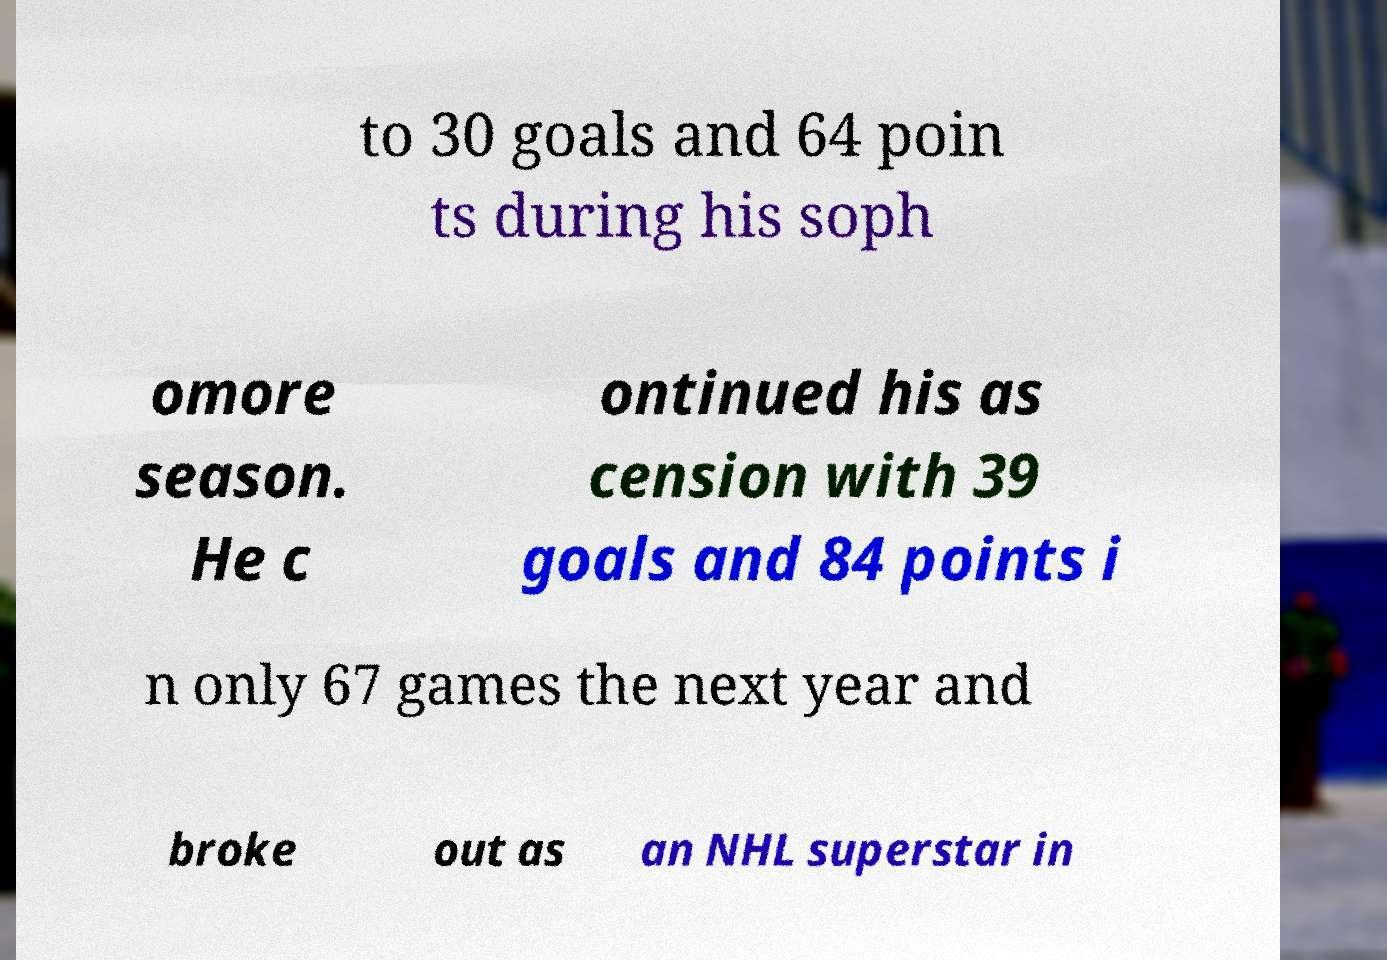I need the written content from this picture converted into text. Can you do that? to 30 goals and 64 poin ts during his soph omore season. He c ontinued his as cension with 39 goals and 84 points i n only 67 games the next year and broke out as an NHL superstar in 